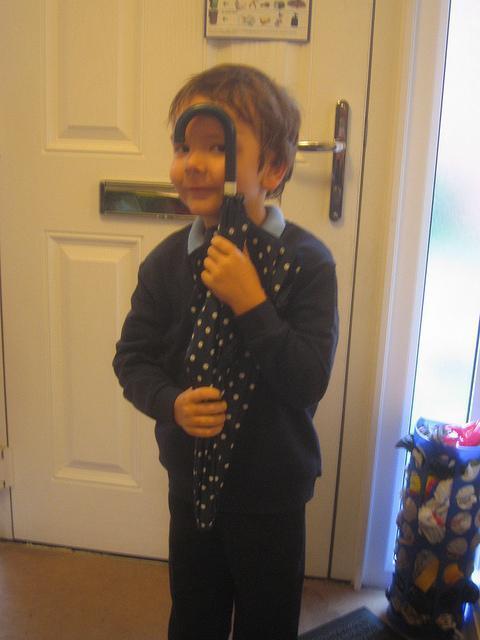How many umbrellas are in the photo?
Give a very brief answer. 1. 